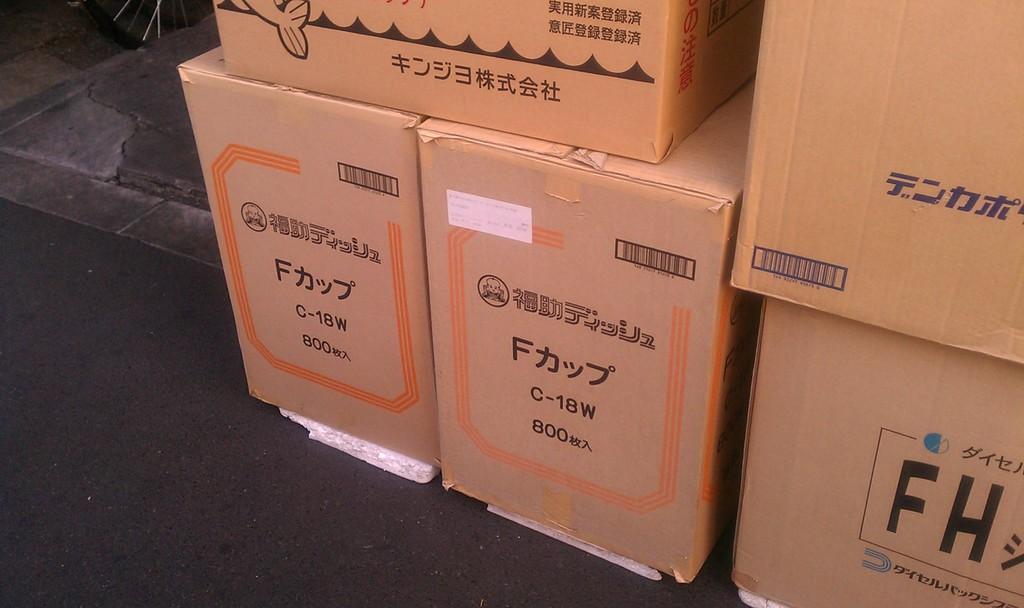How would you summarize this image in a sentence or two? Here we can see cardboard boxes and something written on these cardboard boxes. 